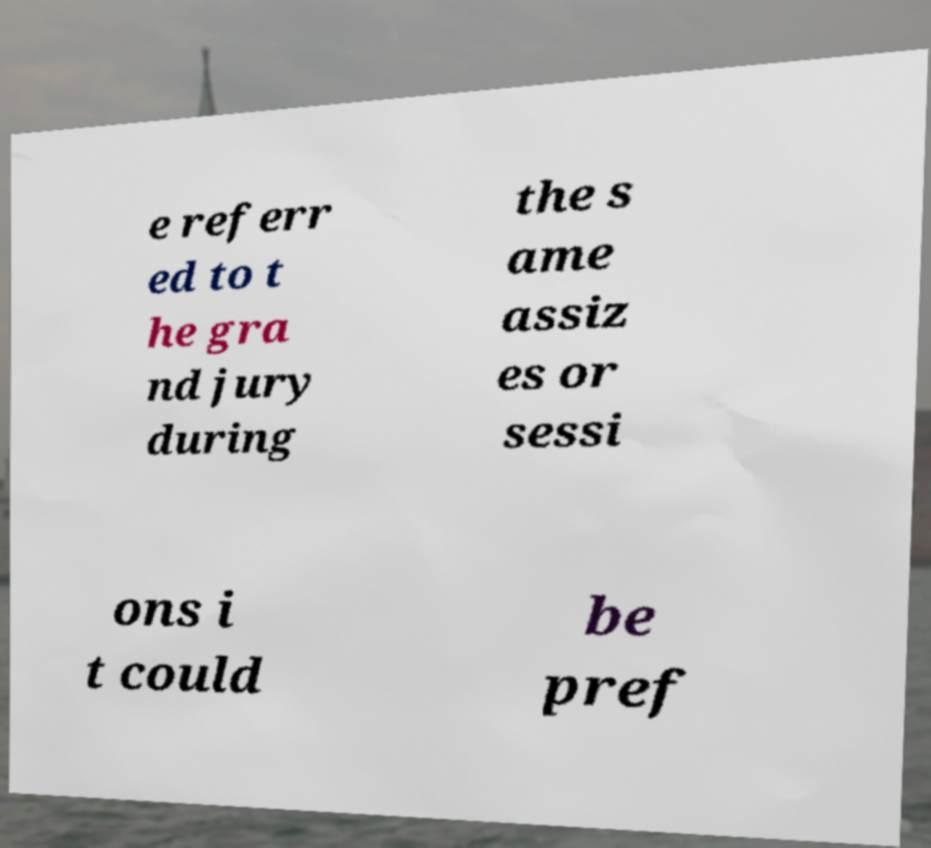What messages or text are displayed in this image? I need them in a readable, typed format. e referr ed to t he gra nd jury during the s ame assiz es or sessi ons i t could be pref 